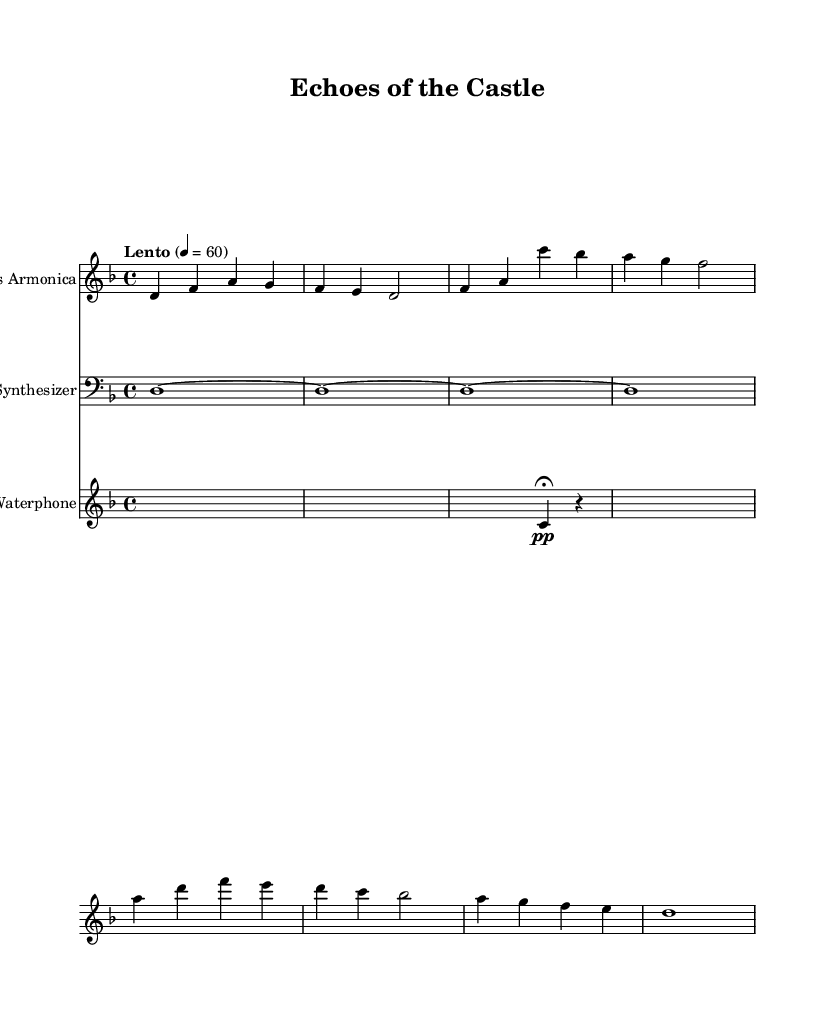What is the key signature of this music? The key signature is indicated by the presence of a flat next to each note, which signifies D minor, as it has one flat (B flat).
Answer: D minor What is the time signature of this music? The time signature is displayed at the beginning of the score, showing 4 over 4, which indicates that there are four beats per measure, and the quarter note gets one beat.
Answer: 4/4 What is the tempo marking of this piece? The tempo marking is located at the beginning of the score, reading "Lento" with a metronome mark of 60, indicating a slow pace.
Answer: Lento 60 How many distinct instruments are used in this piece? The score consists of three distinct staves, each indicating a different instrument: Glass Armonica, Synthesizer, and Waterphone, signifying the use of three different instruments.
Answer: Three Which instrument plays the first line of music? The first staff in the score is labeled "Glass Armonica" and displays the music in its clef. This indicates that the Glass Armonica is the instrument playing the first line.
Answer: Glass Armonica What is the duration of the first note in the Glass Armonica part? The first note in the Glass Armonica section is 'd' and is held for the duration of a quarter note (indicated by '4'), followed by two more quarter notes and then a half note (indicated by '2'). This confirms the first note's duration is a quarter note.
Answer: Quarter note What kind of silence is signified in the Waterphone part during the first measure? The first measure of the Waterphone shows a silence (represented by 's1'), indicating a whole measure's duration of silence, which adds to the ambient quality of the piece.
Answer: Whole note silence 